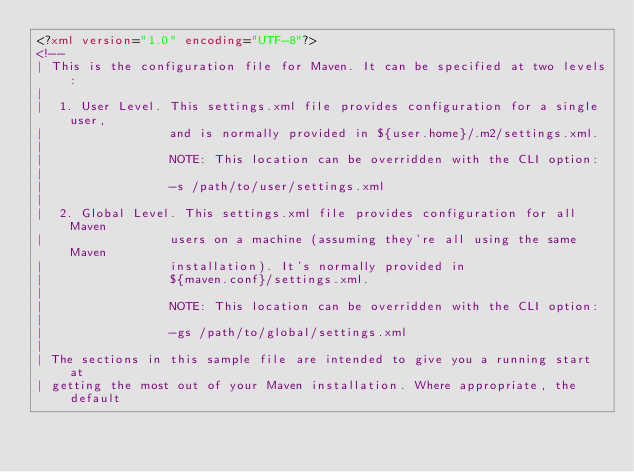<code> <loc_0><loc_0><loc_500><loc_500><_XML_><?xml version="1.0" encoding="UTF-8"?>
<!--
| This is the configuration file for Maven. It can be specified at two levels:
|
|  1. User Level. This settings.xml file provides configuration for a single user,
|                 and is normally provided in ${user.home}/.m2/settings.xml.
|
|                 NOTE: This location can be overridden with the CLI option:
|
|                 -s /path/to/user/settings.xml
|
|  2. Global Level. This settings.xml file provides configuration for all Maven
|                 users on a machine (assuming they're all using the same Maven
|                 installation). It's normally provided in
|                 ${maven.conf}/settings.xml.
|
|                 NOTE: This location can be overridden with the CLI option:
|
|                 -gs /path/to/global/settings.xml
|
| The sections in this sample file are intended to give you a running start at
| getting the most out of your Maven installation. Where appropriate, the default</code> 